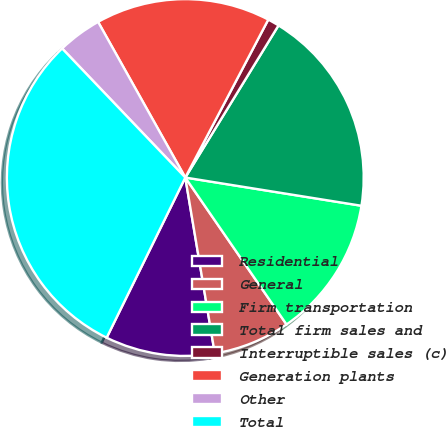Convert chart to OTSL. <chart><loc_0><loc_0><loc_500><loc_500><pie_chart><fcel>Residential<fcel>General<fcel>Firm transportation<fcel>Total firm sales and<fcel>Interruptible sales (c)<fcel>Generation plants<fcel>Other<fcel>Total<nl><fcel>9.91%<fcel>6.96%<fcel>12.87%<fcel>18.78%<fcel>1.05%<fcel>15.83%<fcel>4.0%<fcel>30.61%<nl></chart> 